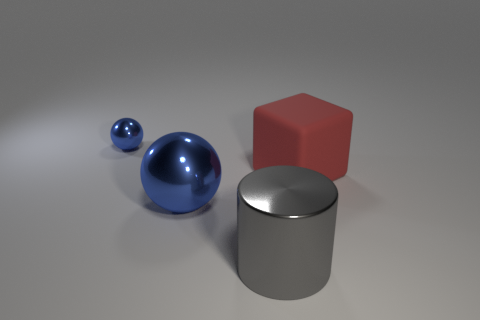Is the cylinder made of the same material as the blue thing behind the big red thing?
Provide a succinct answer. Yes. How many things are either metal spheres behind the cube or red matte things?
Offer a very short reply. 2. Is there a large object of the same color as the shiny cylinder?
Make the answer very short. No. There is a red thing; is it the same shape as the blue metal object that is behind the matte cube?
Keep it short and to the point. No. How many objects are both behind the large gray metal cylinder and left of the big rubber object?
Offer a very short reply. 2. There is another thing that is the same shape as the small blue thing; what is its material?
Ensure brevity in your answer.  Metal. What is the size of the metal thing in front of the big metal thing that is behind the large gray metal cylinder?
Your response must be concise. Large. Are any cubes visible?
Provide a short and direct response. Yes. There is a object that is right of the big blue metal ball and behind the large gray metal cylinder; what material is it?
Your response must be concise. Rubber. Is the number of spheres that are behind the large red rubber object greater than the number of big blue things in front of the large blue shiny thing?
Ensure brevity in your answer.  Yes. 